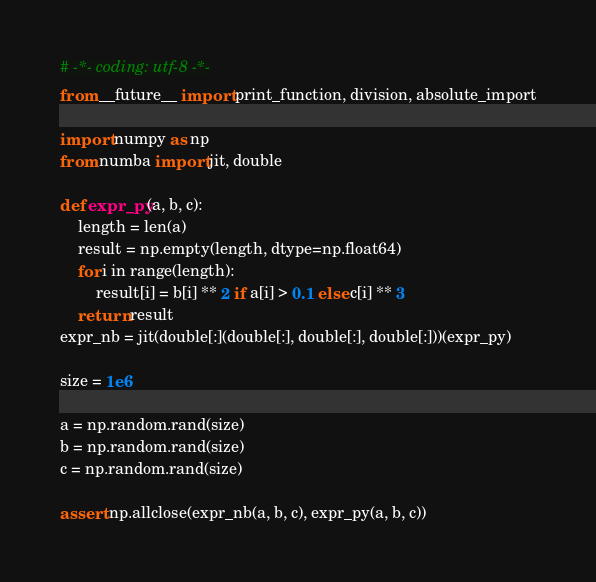<code> <loc_0><loc_0><loc_500><loc_500><_Python_># -*- coding: utf-8 -*-
from __future__ import print_function, division, absolute_import

import numpy as np
from numba import jit, double

def expr_py(a, b, c):
    length = len(a)
    result = np.empty(length, dtype=np.float64)
    for i in range(length):
        result[i] = b[i] ** 2 if a[i] > 0.1 else c[i] ** 3
    return result
expr_nb = jit(double[:](double[:], double[:], double[:]))(expr_py)

size = 1e6

a = np.random.rand(size)
b = np.random.rand(size)
c = np.random.rand(size)

assert np.allclose(expr_nb(a, b, c), expr_py(a, b, c))
</code> 